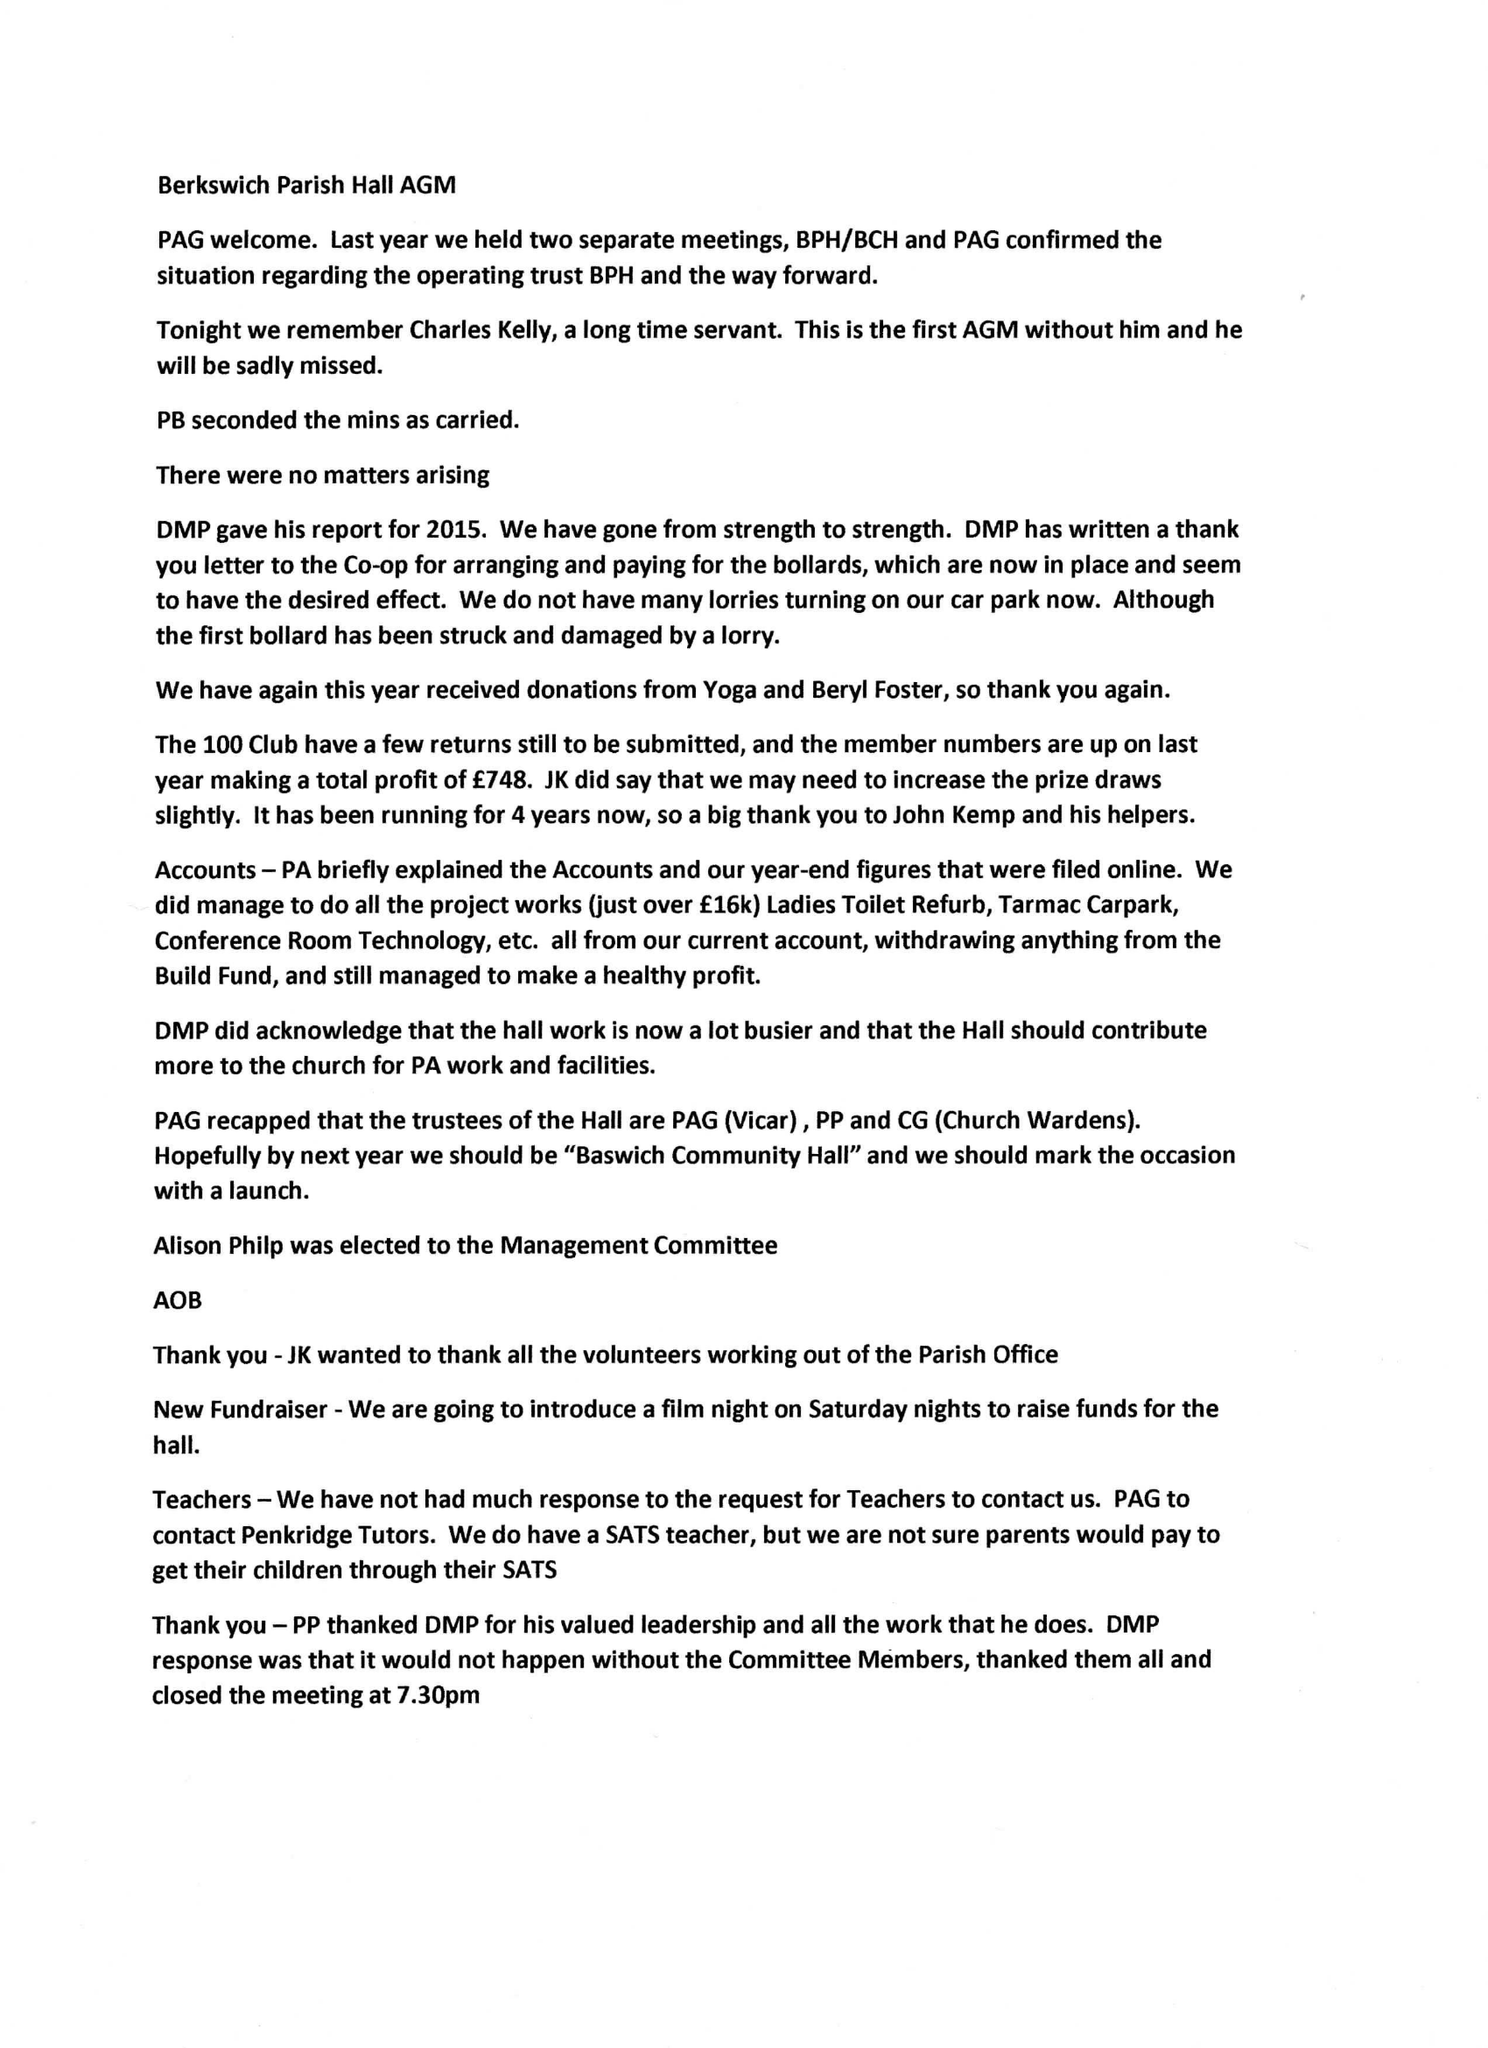What is the value for the report_date?
Answer the question using a single word or phrase. 2015-12-31 